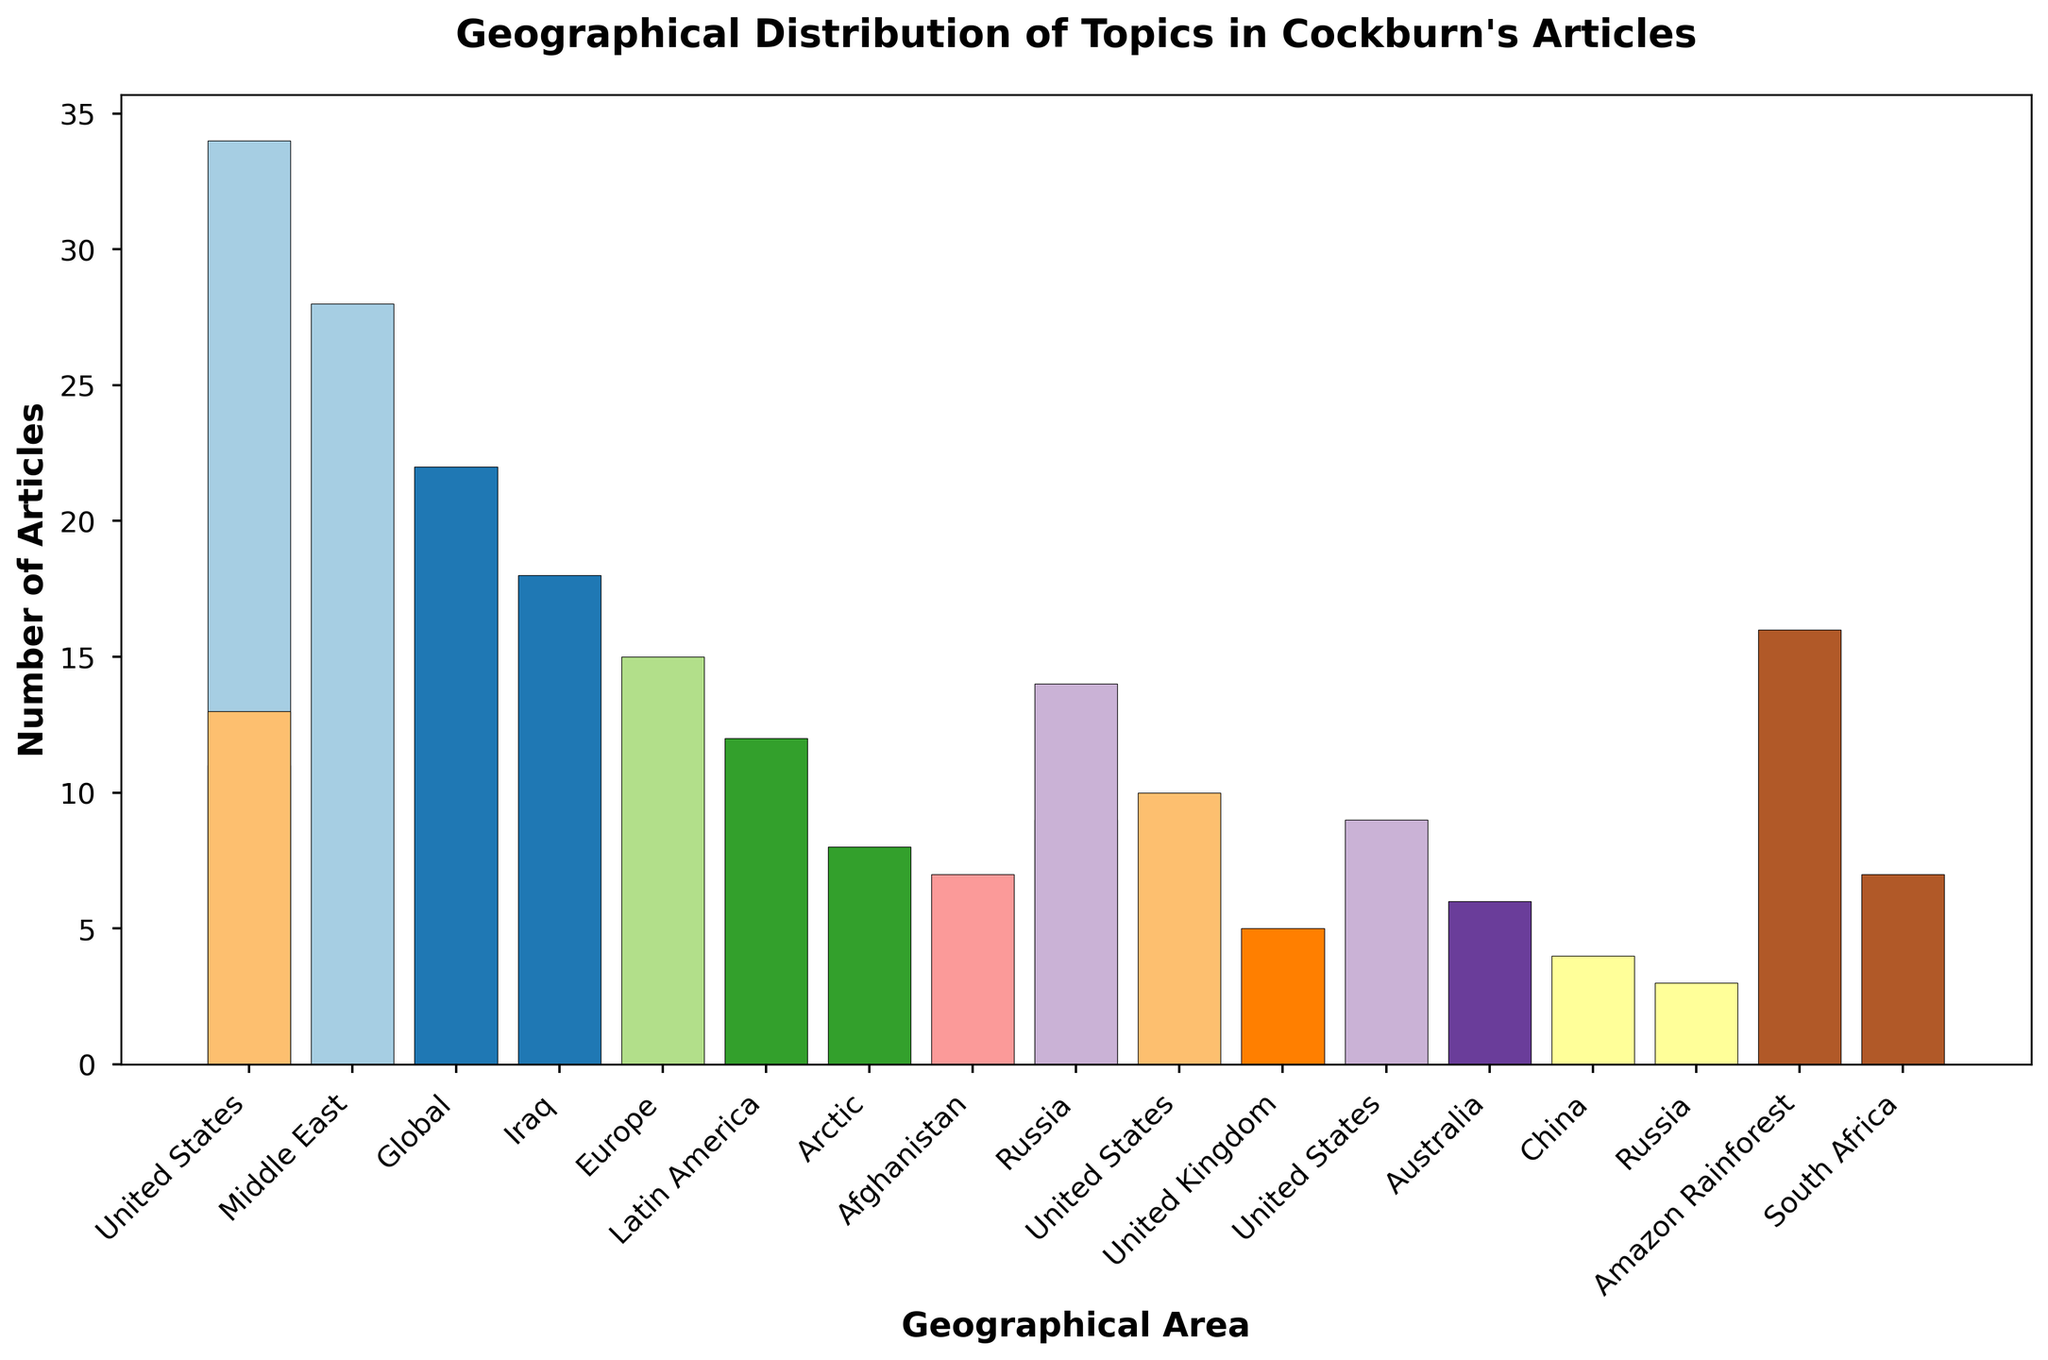What is the total number of articles related to War and Conflict topics? To find the total number of articles related to War and Conflict topics, sum the number of articles for Iraq, Afghanistan, and Israel-Palestine. So, 18 (Iraq) + 7 (Afghanistan) + 16 (Israel-Palestine) = 41.
Answer: 41 Which geographical area has the highest number of articles? By comparing the heights of all bars, the United States has the highest number of articles at 34.
Answer: United States Are there more articles on Environmental Issues in the Global context or Economic Policies in Europe? The number of articles on Environmental Issues in the Global context is 22, while the number of articles on Economic Policies in Europe is 15. Since 22 is greater than 15, Environmental Issues (Global) has more articles.
Answer: Environmental Issues (Global) Which topics have exactly 9 articles? By identifying the bars with a height of 9, the topics are Energy Policies (Russia) and Economic Policies (China).
Answer: Energy Policies (Russia), Economic Policies (China) What is the combined number of articles on topics related to the United States? To find the combined number of articles on topics related to the United States, sum the articles for Politics, Immigration, and Surveillance. So, 34 (Politics) + 11 (Immigration) + 13 (Surveillance) = 58.
Answer: 58 How many more articles are there on Foreign Policy in the Middle East than on Human Rights in Latin America? Subtract the number of articles on Human Rights in Latin America from the number of articles on Foreign Policy in the Middle East. So, 28 (Middle East) - 12 (Latin America) = 16.
Answer: 16 Which topic has the least number of articles, and how many are there? By identifying the shortest bar, the topic with the least number of articles is Labor Rights in South Africa with 4 articles.
Answer: Labor Rights (South Africa), 4 Are there more articles on Media Critique in the United Kingdom or Human Rights in Latin America? There are 10 articles on Media Critique in the United Kingdom and 12 articles on Human Rights in Latin America. Since 12 is greater than 10, Human Rights (Latin America) has more articles.
Answer: Human Rights (Latin America) What is the average number of articles per topic across all geographical areas? To find the average, sum the total number of articles and divide by the number of data points. So, the sum is 270, and there are 19 topics. 270 / 19 ≈ 14.21.
Answer: 14.21 Which geographical area is associated with the Climate Change topic and how many articles are there? The geographical area associated with the Climate Change topic is the Arctic, with 8 articles.
Answer: Arctic, 8 